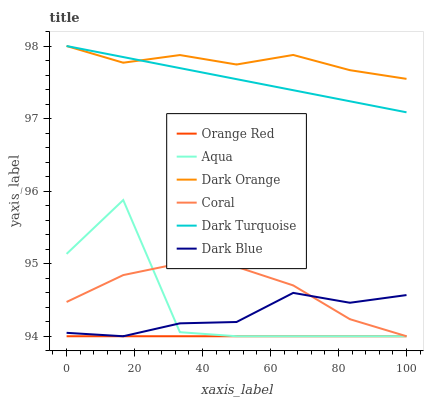Does Dark Turquoise have the minimum area under the curve?
Answer yes or no. No. Does Dark Turquoise have the maximum area under the curve?
Answer yes or no. No. Is Dark Turquoise the smoothest?
Answer yes or no. No. Is Dark Turquoise the roughest?
Answer yes or no. No. Does Dark Turquoise have the lowest value?
Answer yes or no. No. Does Coral have the highest value?
Answer yes or no. No. Is Dark Blue less than Dark Orange?
Answer yes or no. Yes. Is Dark Orange greater than Coral?
Answer yes or no. Yes. Does Dark Blue intersect Dark Orange?
Answer yes or no. No. 